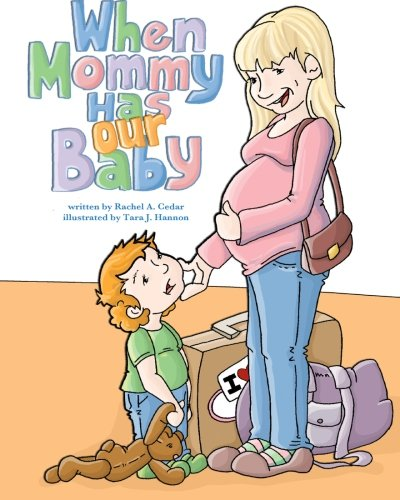Is this a sci-fi book? No, the book 'When Mommy Has Our Baby' is not a sci-fi book; it is focused on real-life parenting and relationship themes. 